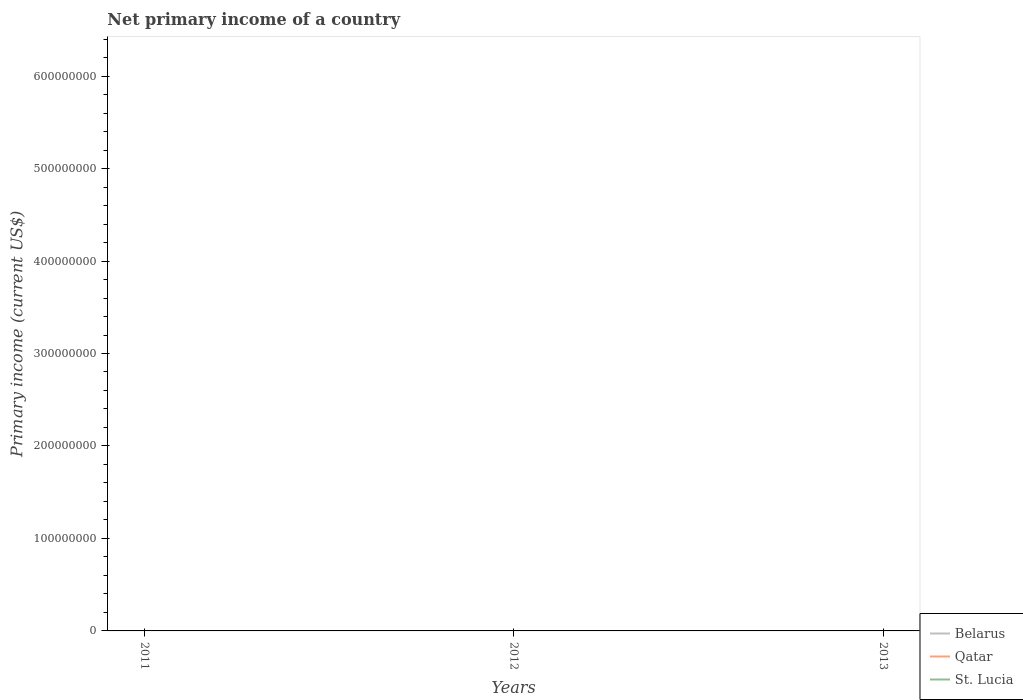What is the difference between the highest and the lowest primary income in Qatar?
Ensure brevity in your answer.  0. Is the primary income in Belarus strictly greater than the primary income in Qatar over the years?
Keep it short and to the point. No. How many lines are there?
Make the answer very short. 0. What is the difference between two consecutive major ticks on the Y-axis?
Offer a terse response. 1.00e+08. Does the graph contain grids?
Make the answer very short. No. How many legend labels are there?
Offer a very short reply. 3. How are the legend labels stacked?
Your response must be concise. Vertical. What is the title of the graph?
Keep it short and to the point. Net primary income of a country. Does "Spain" appear as one of the legend labels in the graph?
Your answer should be compact. No. What is the label or title of the X-axis?
Offer a terse response. Years. What is the label or title of the Y-axis?
Your answer should be compact. Primary income (current US$). What is the Primary income (current US$) of Qatar in 2011?
Provide a short and direct response. 0. What is the Primary income (current US$) in St. Lucia in 2012?
Provide a succinct answer. 0. What is the total Primary income (current US$) in Belarus in the graph?
Give a very brief answer. 0. What is the average Primary income (current US$) of Qatar per year?
Your answer should be very brief. 0. What is the average Primary income (current US$) in St. Lucia per year?
Give a very brief answer. 0. 